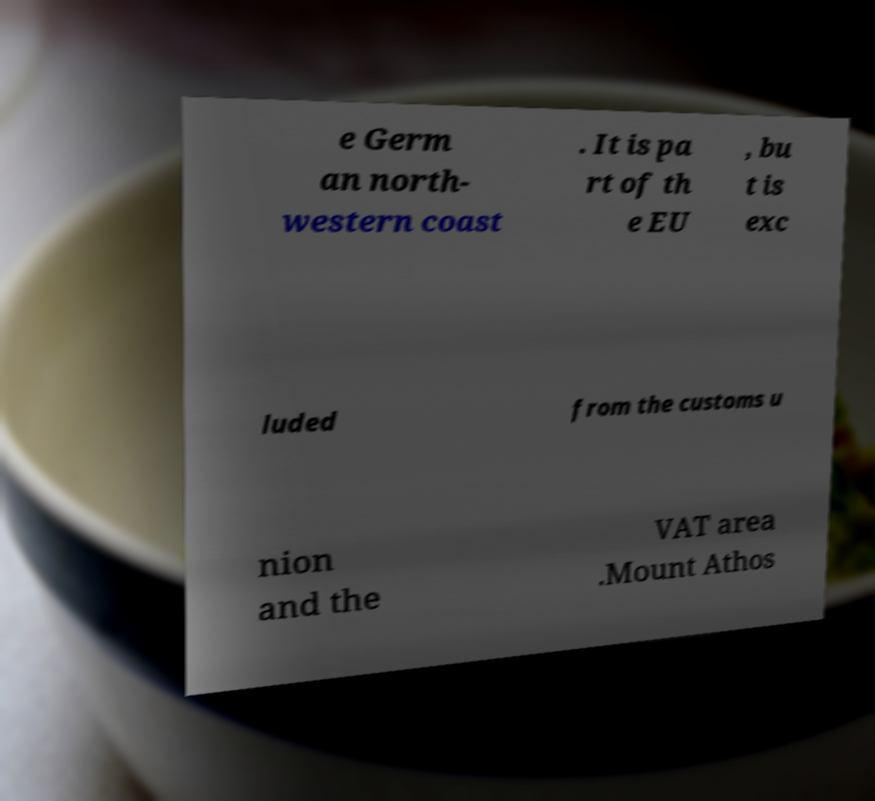What messages or text are displayed in this image? I need them in a readable, typed format. e Germ an north- western coast . It is pa rt of th e EU , bu t is exc luded from the customs u nion and the VAT area .Mount Athos 